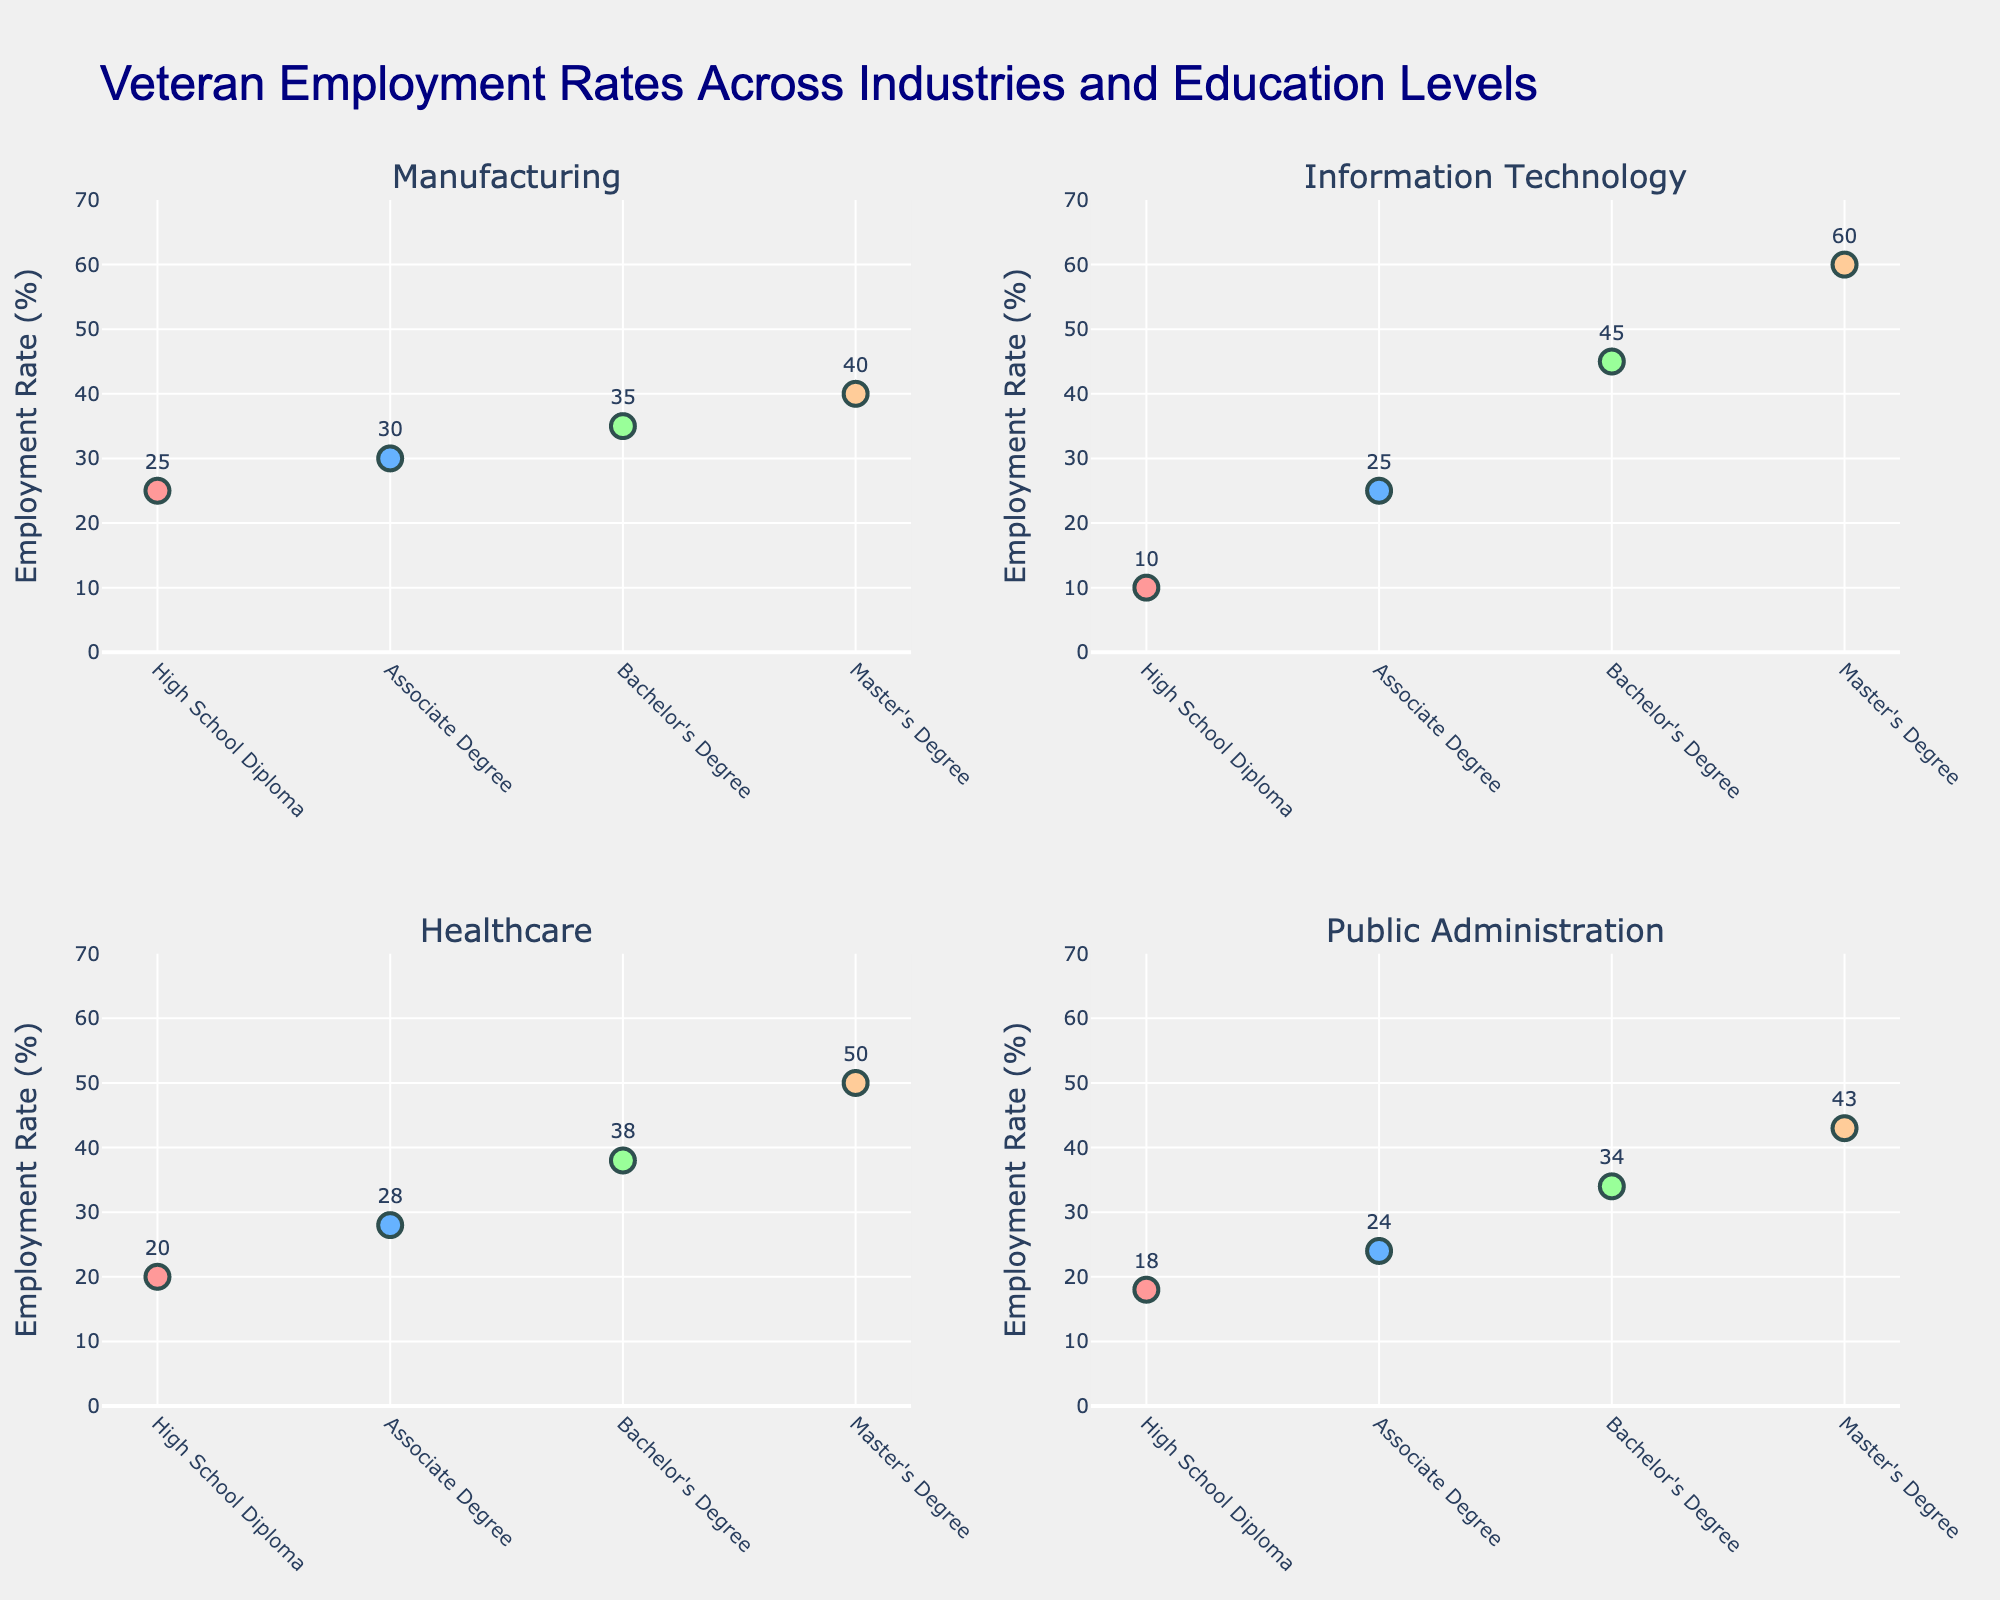what is the title of the figure? The title of the figure is displayed prominently at the top. It reads "Veteran Employment Rates Across Industries and Education Levels". This is clearly shown in a large font.
Answer: Veteran Employment Rates Across Industries and Education Levels What is the Employment Rate for veterans with a Bachelor's Degree in Information Technology? The scatter plot for Information Technology shows a marker for the Bachelor's Degree level, which is labeled with the employment rate. By locating the marker for Bachelor's Degree in that subplot, we see it is labeled as 45%.
Answer: 45% How does the Employment Rate for veterans with a Master's Degree compare between Manufacturing and Healthcare? To compare, look at the markers for Master's Degree in both Manufacturing and Healthcare subplots. In Manufacturing, it's labeled as 40%, and in Healthcare, it's labeled as 50%. Therefore, the Employment Rate for veterans with a Master's Degree is higher in Healthcare by 10%.
Answer: Healthcare is 10% higher Which industry has the lowest employment rate for veterans with a High School Diploma? Look at the markers corresponding to High School Diploma in each subplot. In Manufacturing, it's 25%; in Information Technology, it's 10%; in Healthcare, it's 20%; in Public Administration, it's 18%. The lowest rate is in Information Technology, at 10%.
Answer: Information Technology What’s the difference in Employment Rates between veterans with an Associate Degree and a Bachelor's Degree in Public Administration? In the Public Administration subplot, identify the markers for the Associate Degree and Bachelor's Degree. They are labeled as 24% and 34%, respectively. The difference is calculated as 34% - 24%.
Answer: 10% Which industry shows the highest employment rate for veterans with a Bachelor's Degree? Scan all the subplots for the Bachelor's Degree markers. The rates are 35% for Manufacturing, 45% for Information Technology, 38% for Healthcare, and 34% for Public Administration. The highest rate is in Information Technology, at 45%.
Answer: Information Technology What's the average Employment Rate for veterans with a Master's Degree across all industries? Find the employment rate for the Master's Degree in each industry: Manufacturing is 40%, Information Technology is 60%, Healthcare is 50%, Public Administration is 43%. Summing these up: 40 + 60 + 50 + 43 = 193, and dividing by 4 (number of industries) gives the average: 193 / 4.
Answer: 48.25% How much greater is the Employment Rate for veterans with a Master's Degree in Information Technology compared to a High School Diploma in the same industry? In Information Technology, the rate for a Master's Degree is 60%, and for a High School Diploma, it’s 10%. The difference is found by subtracting the two: 60% - 10%.
Answer: 50% In which industry does the employment rate for veterans increase the most from High School Diploma to Bachelor's Degree? Calculate the increase in Employment Rate from High School Diploma to Bachelor's Degree for each industry: Manufacturing (35% - 25% = 10%), Information Technology (45% - 10% = 35%), Healthcare (38% - 20% = 18%), Public Administration (34% - 18% = 16%). The highest increase is in Information Technology, with a rise of 35%.
Answer: Information Technology 